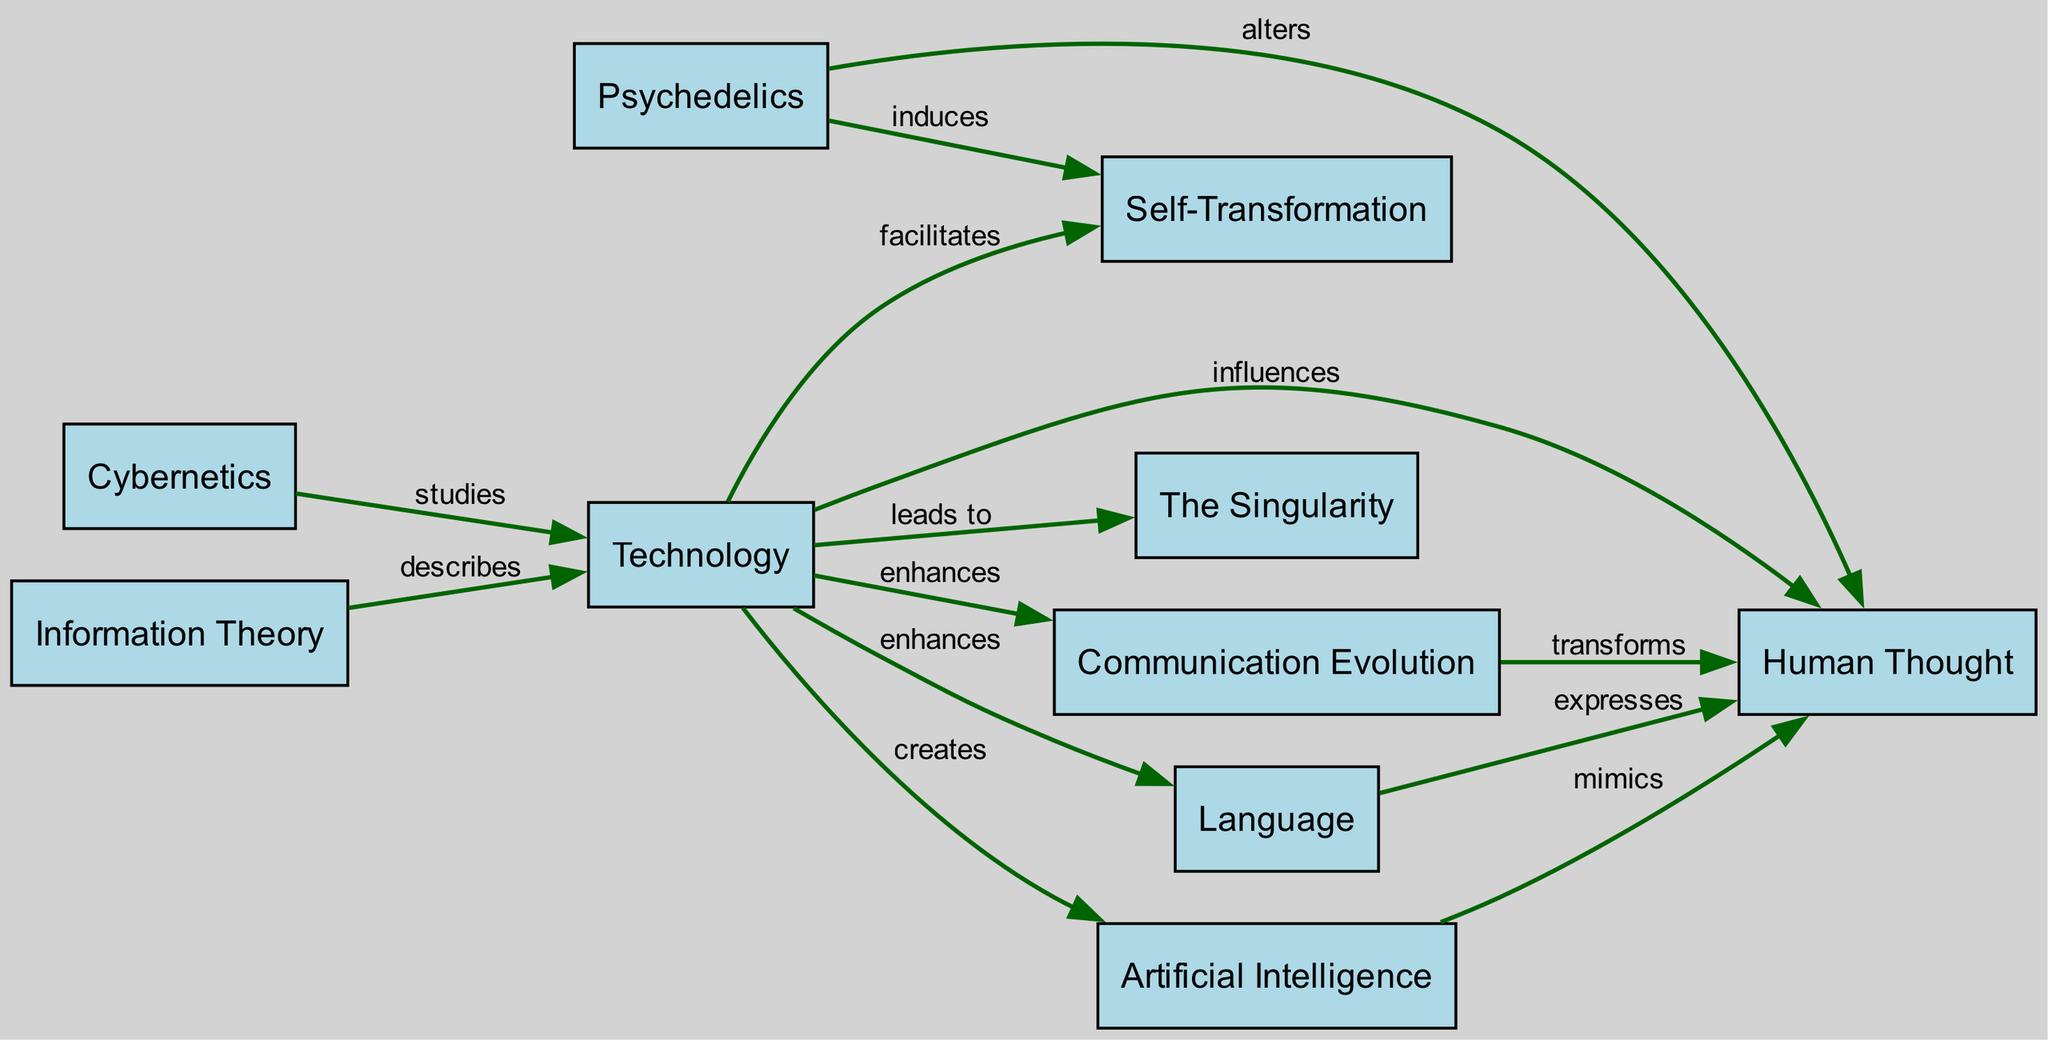What nodes are present in the diagram? The diagram contains ten nodes, which represent concepts relevant to Terence McKenna's philosophy, specifically focusing on the interplay between technology and human thought. These nodes include Technology, Human Thought, Psychedelics, The Singularity, Communication Evolution, Cybernetics, Information Theory, Language, Self-Transformation, and Artificial Intelligence.
Answer: Ten nodes How does Technology influence Human Thought? The diagram shows a direct edge from the Technology node to the Human Thought node labeled "influences," indicating that advancements in technology impact human cognitive processes. This represents the foundational idea in McKenna's philosophy that technology shapes and modifies human thought.
Answer: Influences How many relationships connect Psychedelics with other nodes? Psychedelics have two outgoing relationships in the diagram: one leading to Human Thought labeled “alters” and another leading to Self-Transformation labeled “induces.” This indicates that psychedelics are significant both in altering cognition and fostering personal growth.
Answer: Two What is the relationship between Artificial Intelligence and Human Thought? In the diagram, there is an edge from the Artificial Intelligence node to the Human Thought node labeled "mimics," which implies that AI systems are designed to simulate aspects of human cognition. This connection is crucial in understanding the future implications of technology on thought processes.
Answer: Mimics How does Communication Evolution relate to Human Thought? The diagram connects Communication Evolution to Human Thought via a relationship labeled "transforms." This indicates that advancements in how information is communicated fundamentally change the way humans think and interact, reinforcing McKenna's view on the evolution of consciousness through technology.
Answer: Transforms What does Cybernetics study? In the diagram, there is an edge pointing from Cybernetics to Technology labeled "studies." This indicates that cybernetics is concerned primarily with understanding regulatory systems, especially those that pertain to technological advancements. It highlights the systematic relationships that cybernetics examines between humans and machines.
Answer: Studies Which two nodes are directly linked to Technology that illustrate its impact on cognition and behavior? The Technology node connects directly to Human Thought, labeled "influences," and Self-Transformation, labeled "facilitates." This connection demonstrates how technology impacts not only cognitive functions but also personal development and transformation.
Answer: Influences and facilitates How does Information Theory interact with Technology? The relationship between Information Theory and Technology is shown in the diagram with an edge labeled "describes." This signifies that Information Theory provides a mathematical framework for understanding and quantifying the transmission of information facilitated by various technological means.
Answer: Describes What type of relationship depicts how Language interacts with Technology? The diagram demonstrates that Language is enhanced by Technology, as indicated by the edge labeled "enhances" pointing from Technology to Language. This shows how technological advancements improve and evolve human language, contributing to communication efficiency.
Answer: Enhances 